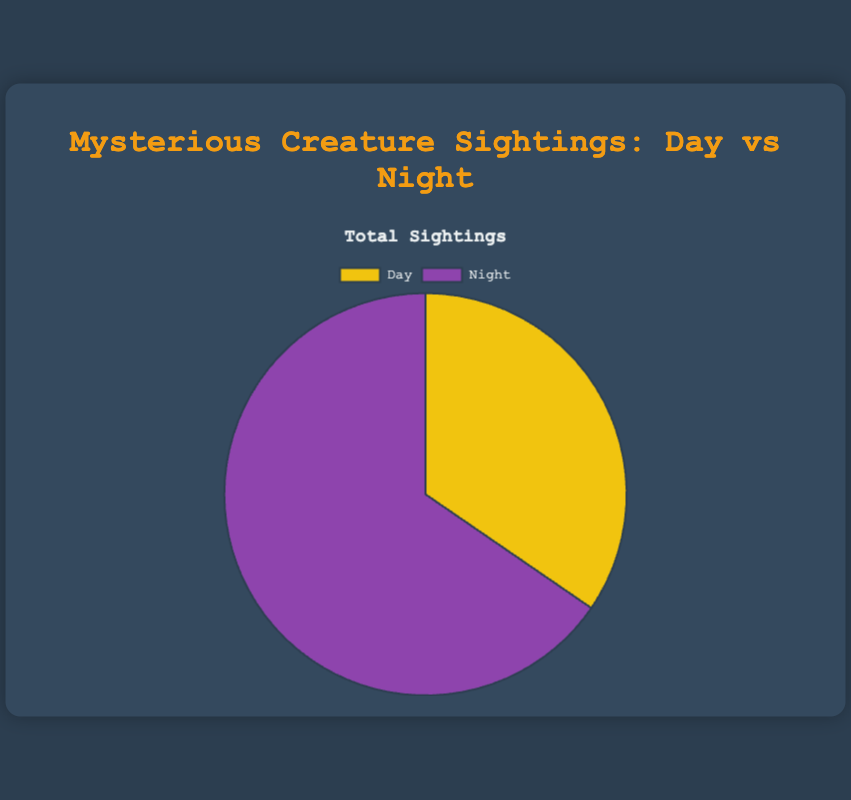What is the total number of sightings during the day? The data shows that there are 15 Bigfoot sightings, 8 Chupacabra sightings, and 5 Mothman sightings during the day. Summing these gives 15 + 8 + 5 = 28 sightings.
Answer: 28 What portion of the total sightings occurred at night? The pie chart shows data for 28 day sightings and 53 night sightings. To find the portion for night, use the formula: (53 / (28 + 53)) * 100 = ~65.4%.
Answer: ~65.4% Which time of day had more total mysterious creature sightings? By comparing the numbers, the pie chart shows 53 night sightings and 28 day sightings. 53 is greater than 28.
Answer: Night What is the difference in the number of sightings between day and night? There are 28 sightings during the day and 53 at night. The difference is 53 - 28 = 25 sightings.
Answer: 25 Which color represents day sightings in the pie chart? The pie chart shows day sightings in yellow and night sightings in purple.
Answer: Yellow How many total sightings of Bigfoot were there? To find the total, add Bigfoot sightings during the day and night. That's 15 (day) + 10 (night) = 25.
Answer: 25 Are there more sightings of Chupacabra at night compared to day? According to the data, there are 25 sightings at night and 8 during the day. 25 is greater than 8.
Answer: Yes What is the average number of sightings per creature during the night? To calculate the average, add night sightings for all creatures: 10 (Bigfoot) + 25 (Chupacabra) + 18 (Mothman) = 53. There are 3 creatures, so the average is 53 / 3 = ~17.7 sightings per creature.
Answer: ~17.7 Which creature had the most total sightings? Summing the sightings for each creature: Bigfoot (25), Chupacabra (33), Mothman (23). Chupacabra has the highest total.
Answer: Chupacabra What fraction of all sightings does Mothman account for? Adding the total sightings for all creatures: 28 (day) + 53 (night) = 81. Mothman has a total of 5 (day) + 18 (night) = 23 sightings. Fraction: 23 / 81 = ~0.284.
Answer: ~0.284 